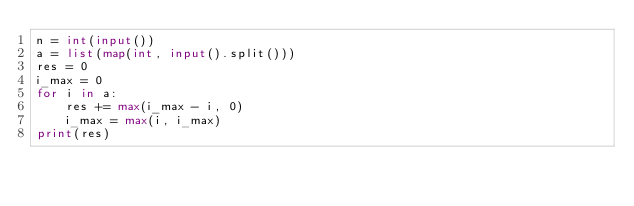Convert code to text. <code><loc_0><loc_0><loc_500><loc_500><_Python_>n = int(input())
a = list(map(int, input().split()))
res = 0
i_max = 0
for i in a:
    res += max(i_max - i, 0)
    i_max = max(i, i_max)
print(res)</code> 